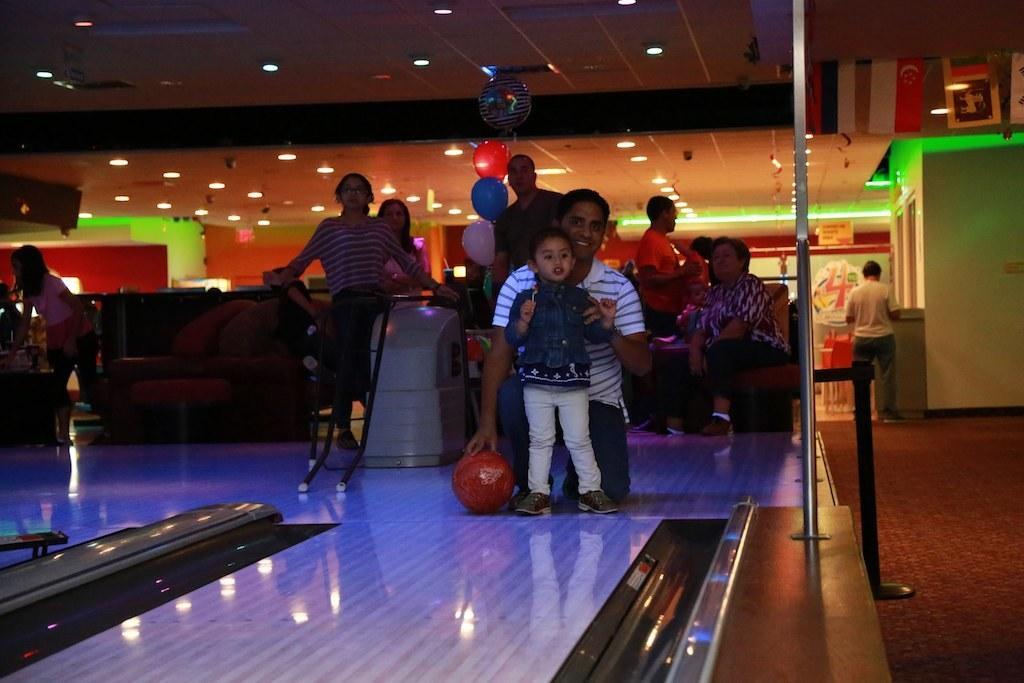Please provide a concise description of this image. As we can see in the image there are group of people, wall, lights and ball. 